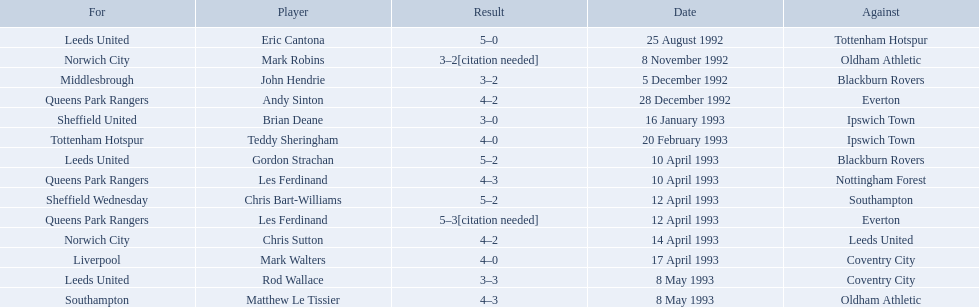Who are all the players? Eric Cantona, Mark Robins, John Hendrie, Andy Sinton, Brian Deane, Teddy Sheringham, Gordon Strachan, Les Ferdinand, Chris Bart-Williams, Les Ferdinand, Chris Sutton, Mark Walters, Rod Wallace, Matthew Le Tissier. What were their results? 5–0, 3–2[citation needed], 3–2, 4–2, 3–0, 4–0, 5–2, 4–3, 5–2, 5–3[citation needed], 4–2, 4–0, 3–3, 4–3. Which player tied with mark robins? John Hendrie. 